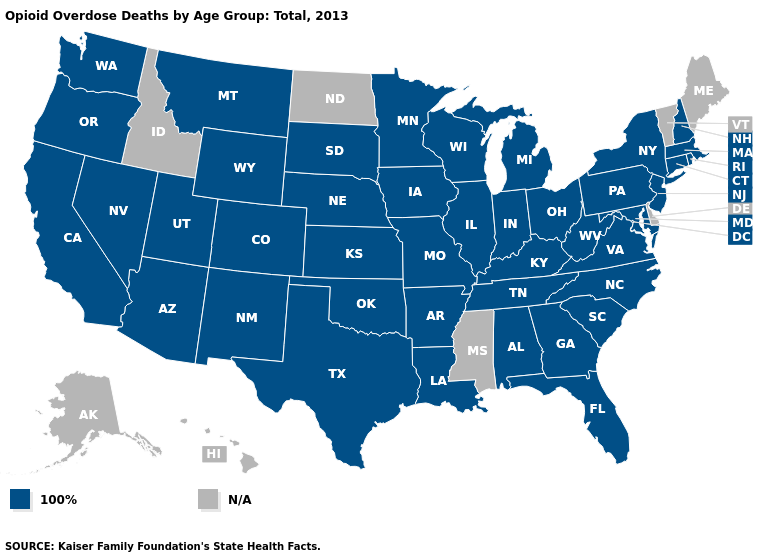Name the states that have a value in the range N/A?
Concise answer only. Alaska, Delaware, Hawaii, Idaho, Maine, Mississippi, North Dakota, Vermont. Among the states that border Wyoming , which have the lowest value?
Short answer required. Colorado, Montana, Nebraska, South Dakota, Utah. Which states have the lowest value in the Northeast?
Answer briefly. Connecticut, Massachusetts, New Hampshire, New Jersey, New York, Pennsylvania, Rhode Island. Name the states that have a value in the range N/A?
Be succinct. Alaska, Delaware, Hawaii, Idaho, Maine, Mississippi, North Dakota, Vermont. Does the first symbol in the legend represent the smallest category?
Be succinct. Yes. What is the highest value in states that border Louisiana?
Give a very brief answer. 100%. Which states have the lowest value in the Northeast?
Quick response, please. Connecticut, Massachusetts, New Hampshire, New Jersey, New York, Pennsylvania, Rhode Island. Name the states that have a value in the range 100%?
Write a very short answer. Alabama, Arizona, Arkansas, California, Colorado, Connecticut, Florida, Georgia, Illinois, Indiana, Iowa, Kansas, Kentucky, Louisiana, Maryland, Massachusetts, Michigan, Minnesota, Missouri, Montana, Nebraska, Nevada, New Hampshire, New Jersey, New Mexico, New York, North Carolina, Ohio, Oklahoma, Oregon, Pennsylvania, Rhode Island, South Carolina, South Dakota, Tennessee, Texas, Utah, Virginia, Washington, West Virginia, Wisconsin, Wyoming. What is the value of Kentucky?
Short answer required. 100%. What is the lowest value in the USA?
Be succinct. 100%. What is the lowest value in the Northeast?
Be succinct. 100%. Among the states that border New Jersey , which have the lowest value?
Write a very short answer. New York, Pennsylvania. Which states have the highest value in the USA?
Answer briefly. Alabama, Arizona, Arkansas, California, Colorado, Connecticut, Florida, Georgia, Illinois, Indiana, Iowa, Kansas, Kentucky, Louisiana, Maryland, Massachusetts, Michigan, Minnesota, Missouri, Montana, Nebraska, Nevada, New Hampshire, New Jersey, New Mexico, New York, North Carolina, Ohio, Oklahoma, Oregon, Pennsylvania, Rhode Island, South Carolina, South Dakota, Tennessee, Texas, Utah, Virginia, Washington, West Virginia, Wisconsin, Wyoming. Does the first symbol in the legend represent the smallest category?
Answer briefly. Yes. 